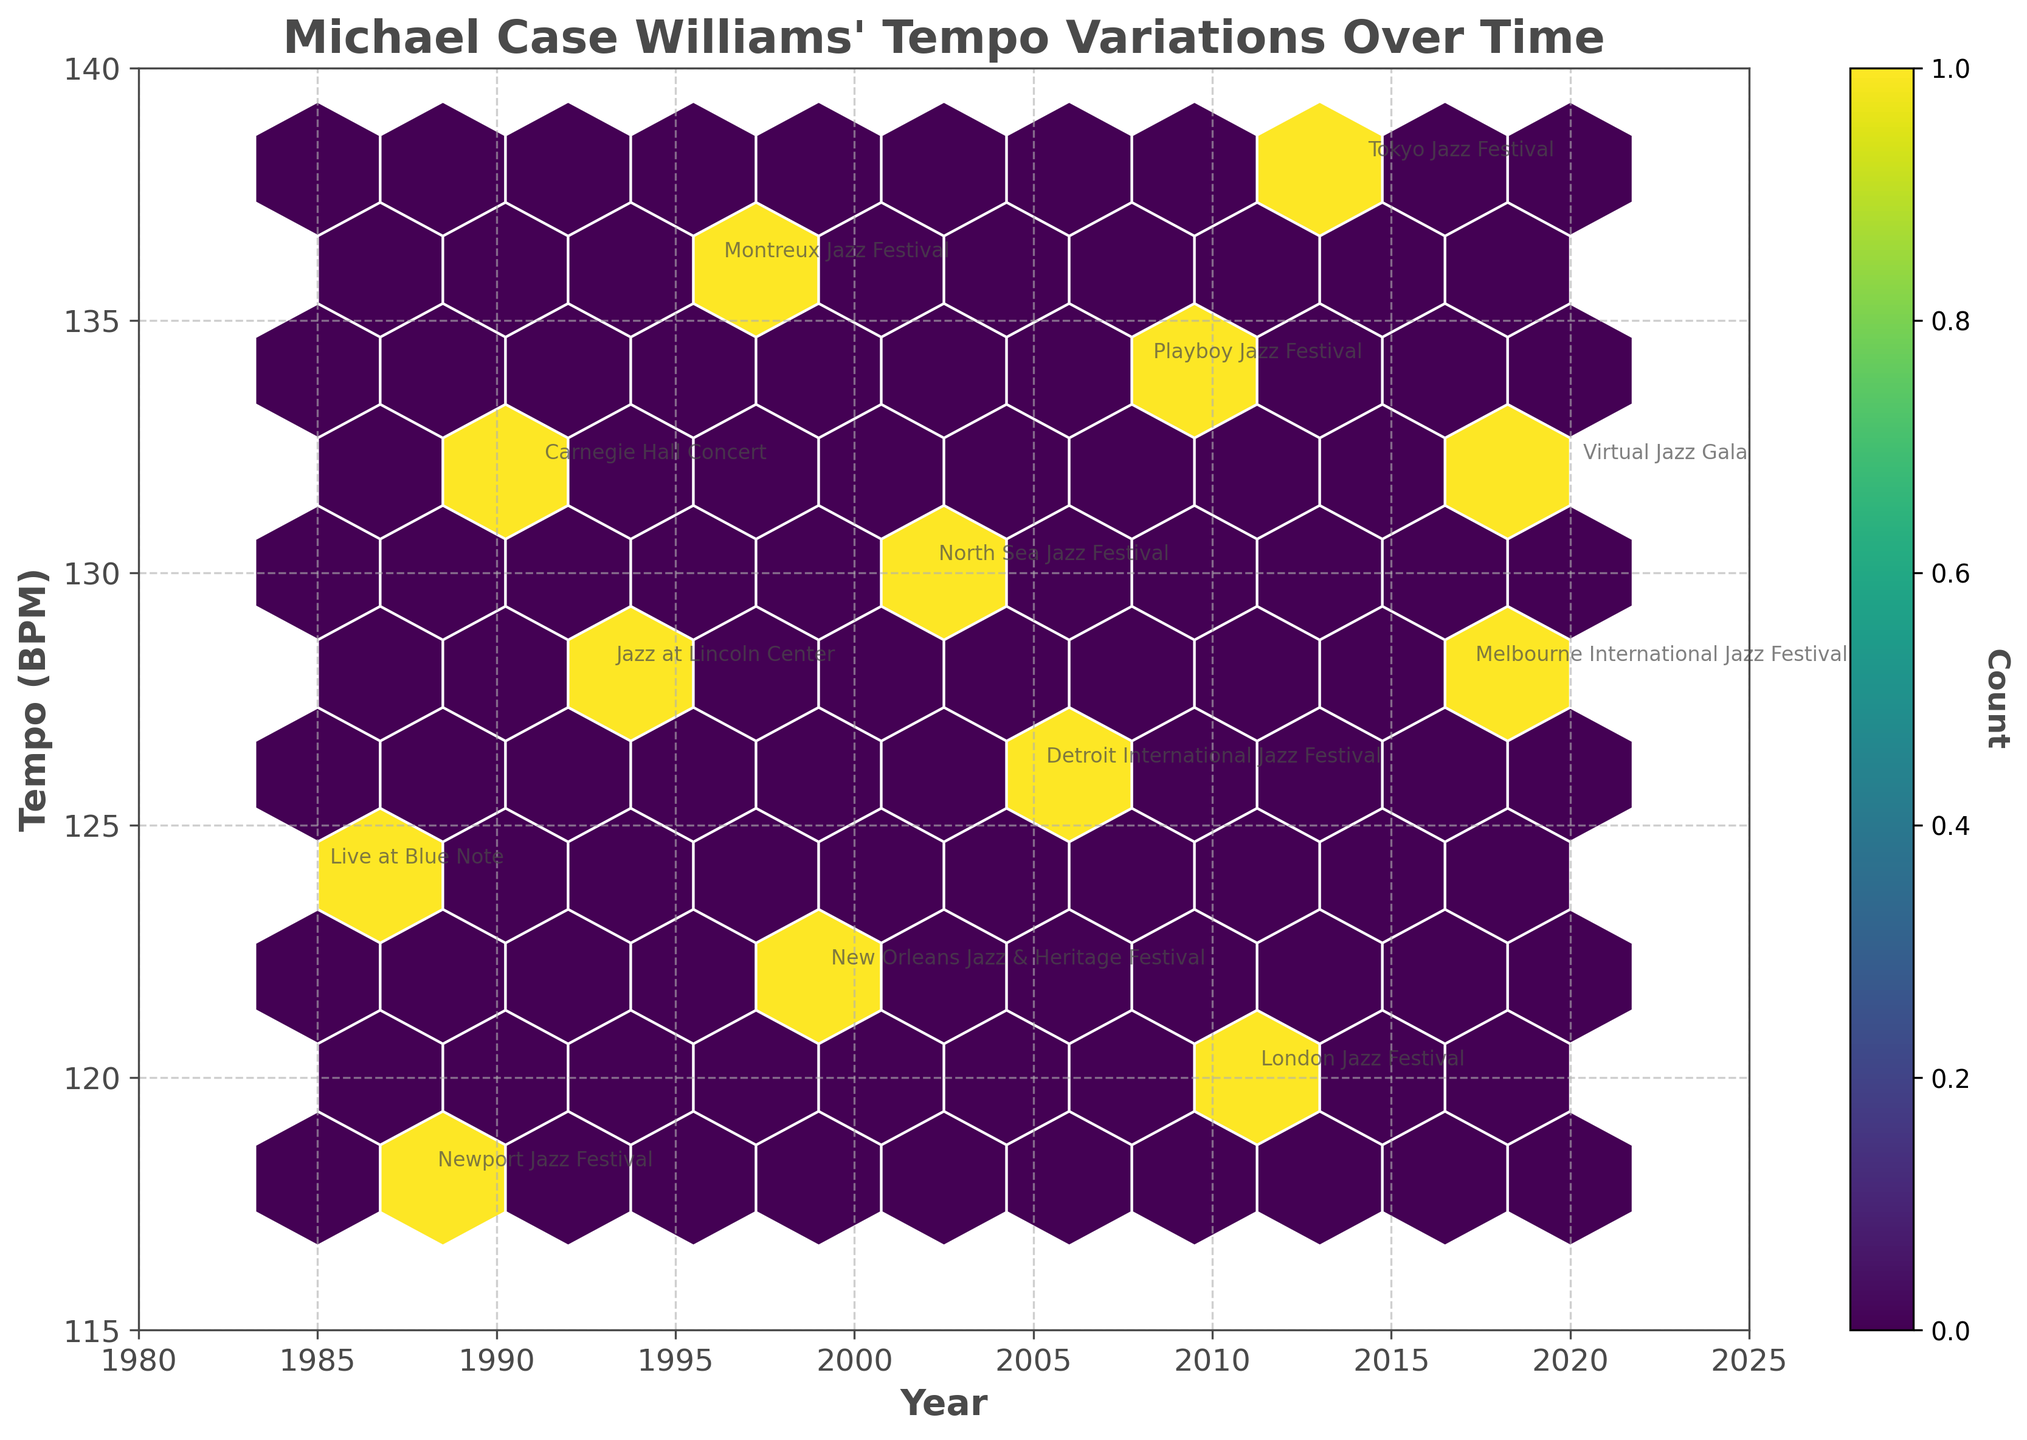What does the x-axis represent in the plot? The x-axis represents the years of Williams' performances, ranging from 1980 to 2025.
Answer: years of performances What is the hexbin plot's title? The title is prominently displayed at the top of the plot and reads, "Michael Case Williams' Tempo Variations Over Time".
Answer: Michael Case Williams' Tempo Variations Over Time How many years are covered in the plot? By observing the range on the x-axis, it is clear that performances are recorded from 1985 to 2020.
Answer: 36 years What is the color used to represent higher data density in the hexbin plot? Typically in a viridis colormap, higher densities are often represented by colors toward the yellow spectrum.
Answer: yellow Which performance has the highest tempo (BPM)? By locating the uppermost point on the plot, the Tokyo Jazz Festival in 2014, with a tempo of 138 BPM, stands out as the highest.
Answer: Tokyo Jazz Festival What is the highest recorded tempo in BPM? The highest tempo can be found by looking at the y-axis maximum point tagged, which is 138 BPM.
Answer: 138 BPM Which performance occurred in the year 2005? By tracing the x-axis to the year 2005, the annotated performance is the Detroit International Jazz Festival.
Answer: Detroit International Jazz Festival What is the median tempo (BPM) of the performances? To find the median, identify the middle tempo value from the sorted list of all tempos: [118, 120, 122, 124, 126, 128, 128, 130, 132, 132, 134, 136, 138]. The middle value is 128 BPM.
Answer: 128 BPM Did Michael Case Williams perform more often at tempos above or below 130 BPM? By counting the data points above and below 130 BPM, there are 7 above and 6 below, indicating more performances at tempos above 130 BPM.
Answer: above 130 BPM Is there any visible year with no performance recorded? By examining the plot and the distribution of points on the x-axis, it appears there are no significant gaps without annotations from 1985 to 2020.
Answer: no 